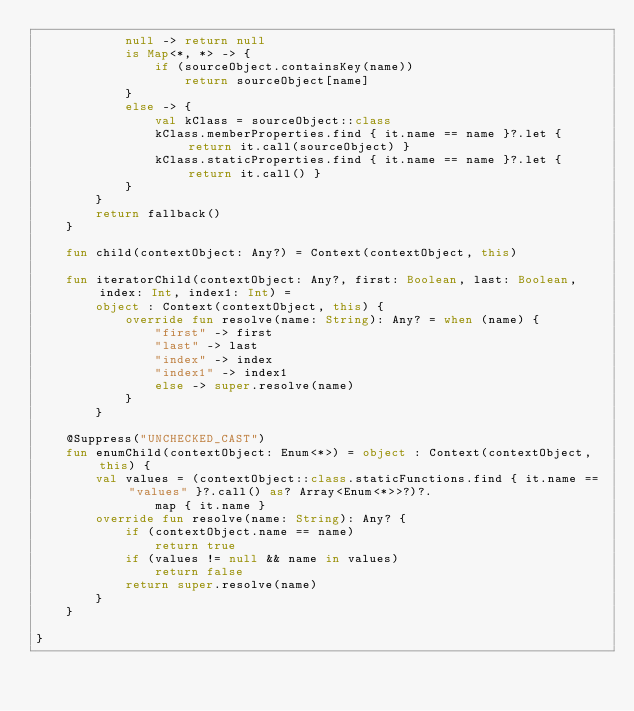Convert code to text. <code><loc_0><loc_0><loc_500><loc_500><_Kotlin_>            null -> return null
            is Map<*, *> -> {
                if (sourceObject.containsKey(name))
                    return sourceObject[name]
            }
            else -> {
                val kClass = sourceObject::class
                kClass.memberProperties.find { it.name == name }?.let { return it.call(sourceObject) }
                kClass.staticProperties.find { it.name == name }?.let { return it.call() }
            }
        }
        return fallback()
    }

    fun child(contextObject: Any?) = Context(contextObject, this)

    fun iteratorChild(contextObject: Any?, first: Boolean, last: Boolean, index: Int, index1: Int) =
        object : Context(contextObject, this) {
            override fun resolve(name: String): Any? = when (name) {
                "first" -> first
                "last" -> last
                "index" -> index
                "index1" -> index1
                else -> super.resolve(name)
            }
        }

    @Suppress("UNCHECKED_CAST")
    fun enumChild(contextObject: Enum<*>) = object : Context(contextObject, this) {
        val values = (contextObject::class.staticFunctions.find { it.name == "values" }?.call() as? Array<Enum<*>>?)?.
                map { it.name }
        override fun resolve(name: String): Any? {
            if (contextObject.name == name)
                return true
            if (values != null && name in values)
                return false
            return super.resolve(name)
        }
    }

}
</code> 